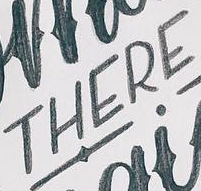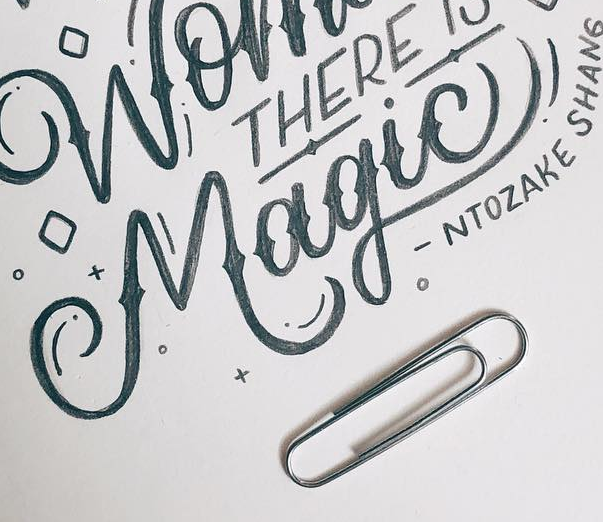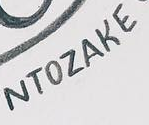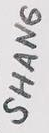Read the text from these images in sequence, separated by a semicolon. THERE; Magic!; NTOZAKE; SHANG 